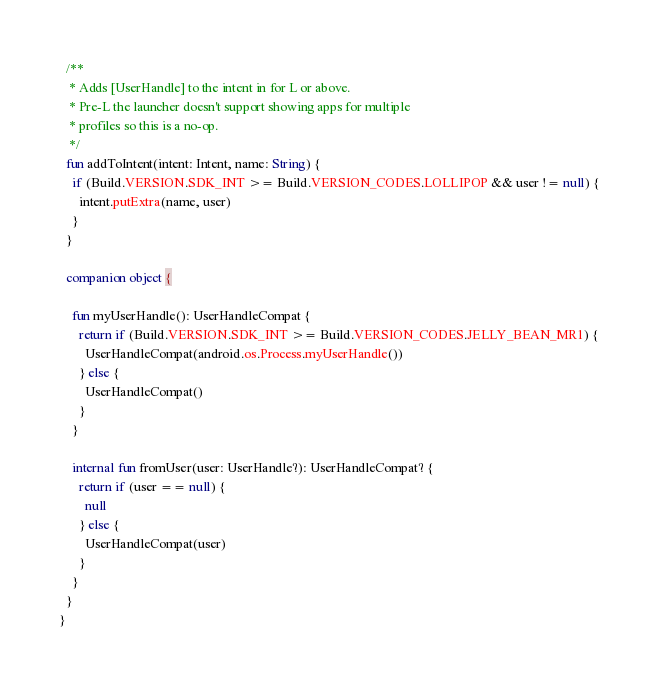<code> <loc_0><loc_0><loc_500><loc_500><_Kotlin_>
  /**
   * Adds [UserHandle] to the intent in for L or above.
   * Pre-L the launcher doesn't support showing apps for multiple
   * profiles so this is a no-op.
   */
  fun addToIntent(intent: Intent, name: String) {
    if (Build.VERSION.SDK_INT >= Build.VERSION_CODES.LOLLIPOP && user != null) {
      intent.putExtra(name, user)
    }
  }

  companion object {

    fun myUserHandle(): UserHandleCompat {
      return if (Build.VERSION.SDK_INT >= Build.VERSION_CODES.JELLY_BEAN_MR1) {
        UserHandleCompat(android.os.Process.myUserHandle())
      } else {
        UserHandleCompat()
      }
    }

    internal fun fromUser(user: UserHandle?): UserHandleCompat? {
      return if (user == null) {
        null
      } else {
        UserHandleCompat(user)
      }
    }
  }
}</code> 